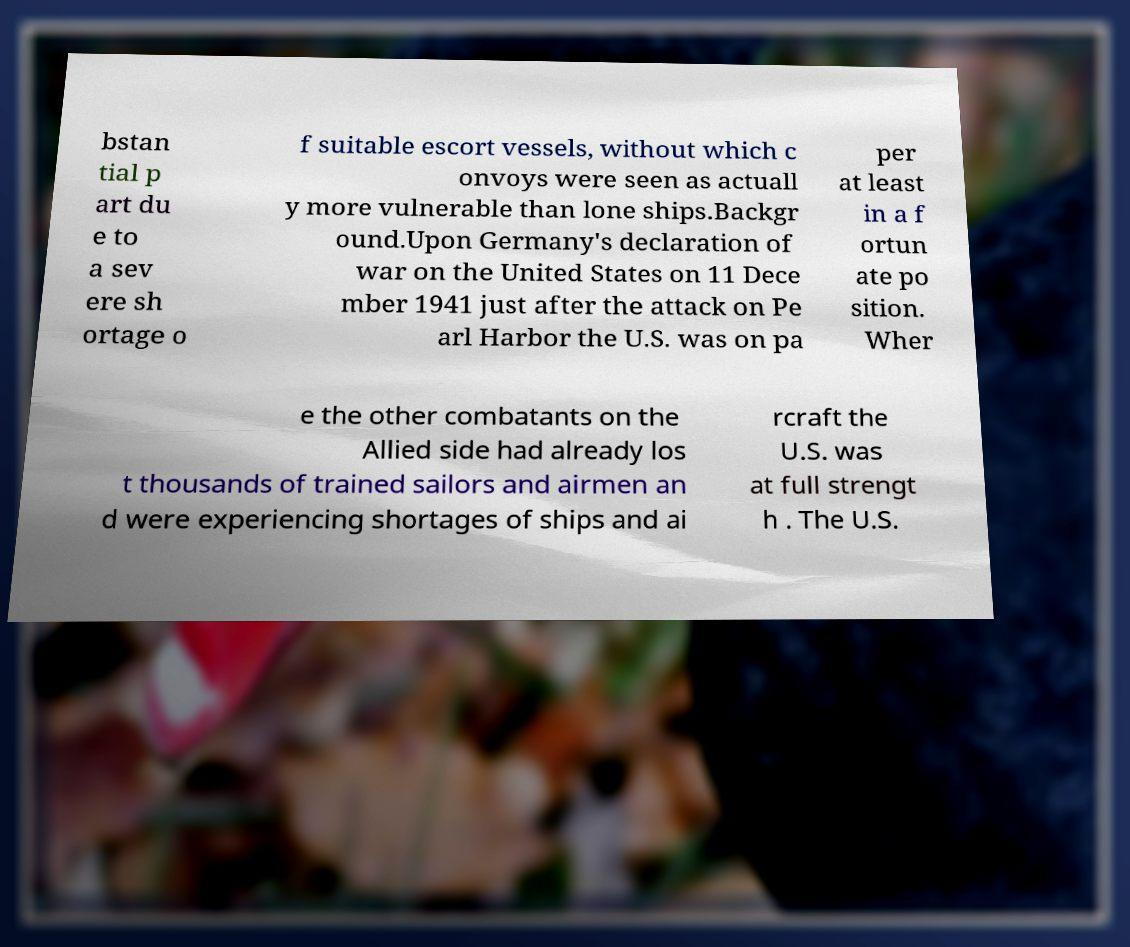Could you extract and type out the text from this image? bstan tial p art du e to a sev ere sh ortage o f suitable escort vessels, without which c onvoys were seen as actuall y more vulnerable than lone ships.Backgr ound.Upon Germany's declaration of war on the United States on 11 Dece mber 1941 just after the attack on Pe arl Harbor the U.S. was on pa per at least in a f ortun ate po sition. Wher e the other combatants on the Allied side had already los t thousands of trained sailors and airmen an d were experiencing shortages of ships and ai rcraft the U.S. was at full strengt h . The U.S. 